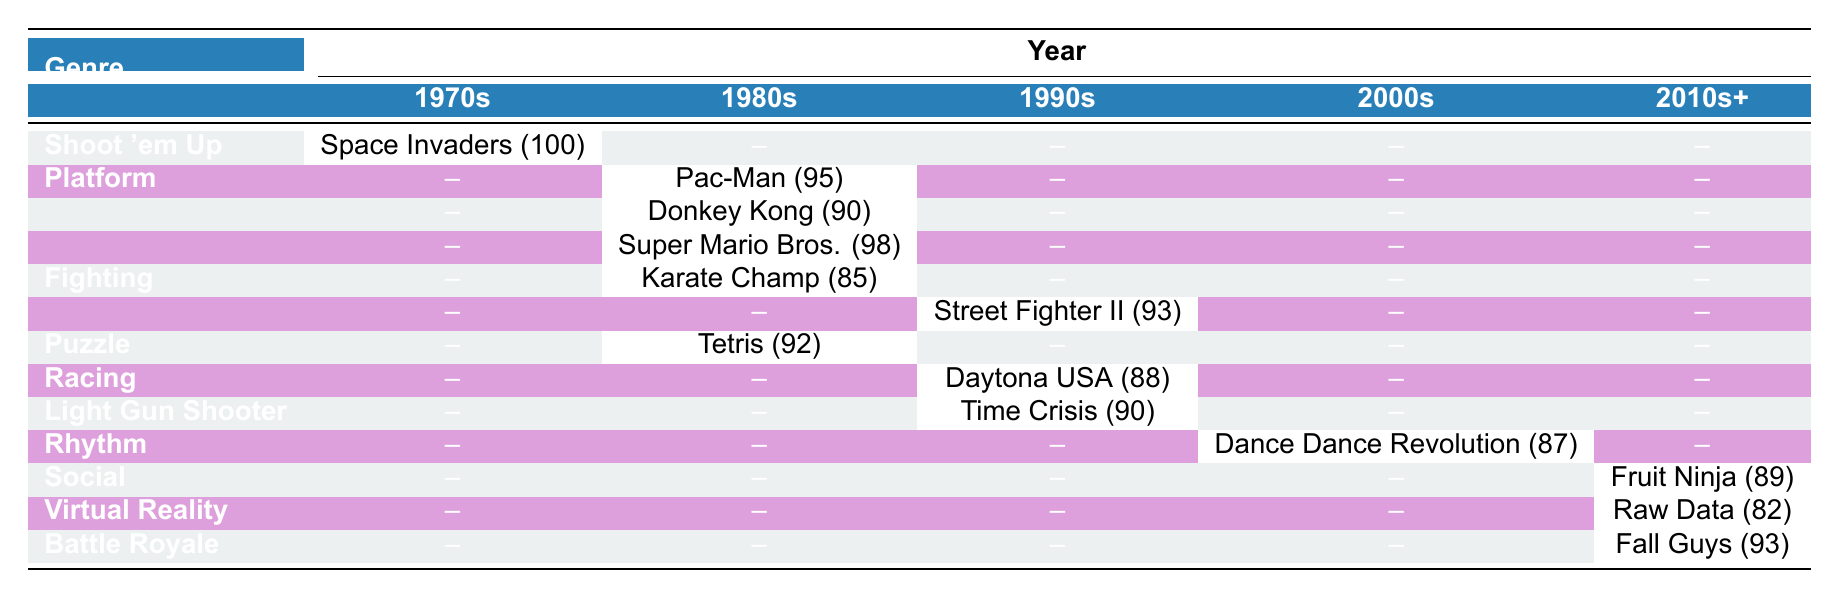What is the highest popularity score recorded in the 1970s? Space Invaders, the only game listed in the 1970s, has a popularity score of 100.
Answer: 100 Which genre had the highest popularity score in the 1980s? The Platform genre includes two games: Pac-Man with a score of 95 and Donkey Kong with 90. The highest score is from Pac-Man.
Answer: Pac-Man (95) How many genres are represented in the 1990s? The table shows three genres in the 1990s: Fighting (Street Fighter II), Racing (Daytona USA), and Light Gun Shooter (Time Crisis). Therefore, there are three genres.
Answer: 3 Is there a game from the 2000s that has a higher popularity score than 85? Dance Dance Revolution from the 2000s has a score of 87, which is greater than 85. Thus, the statement is true.
Answer: Yes What is the average popularity score of games in the 2010s? The games from the 2010s are Fruit Ninja (89) and Raw Data (82). Adding these scores gives 89 + 82 = 171. There are 2 games, so the average is 171 / 2 = 85.5.
Answer: 85.5 Which genre has the lowest popularity score and what is that score? The Virtual Reality genre is represented by Raw Data, which has a popularity score of 82, the lowest in the table.
Answer: Virtual Reality (82) How does the popularity score of Fall Guys compare to that of Tetris? Fall Guys has a score of 93, while Tetris has a score of 92. Since 93 is greater than 92, Fall Guys has a higher score.
Answer: Fall Guys is higher (93 > 92) What is the total number of games listed in the table? The table lists one game from 1970s, four from 1980s, three from 1990s, one from 2000s, two from 2010s, and one from 2020. Adding these gives 1 + 4 + 3 + 1 + 2 + 1 = 12.
Answer: 12 